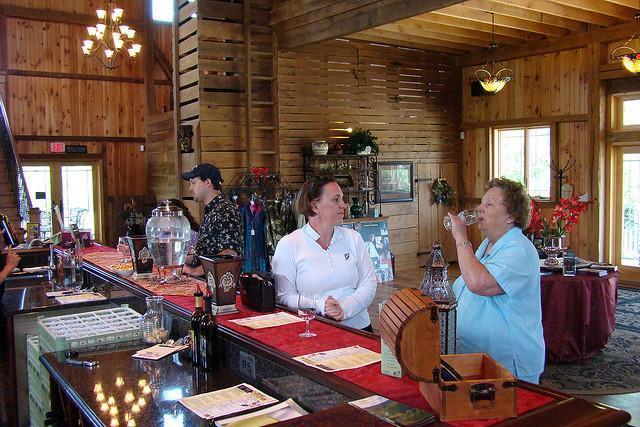How many dining tables are visible?
Give a very brief answer. 2. How many people are in the picture?
Give a very brief answer. 3. How many mice are in this scene?
Give a very brief answer. 0. 